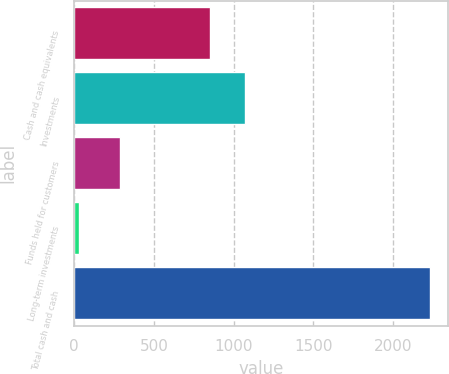Convert chart. <chart><loc_0><loc_0><loc_500><loc_500><bar_chart><fcel>Cash and cash equivalents<fcel>Investments<fcel>Funds held for customers<fcel>Long-term investments<fcel>Total cash and cash<nl><fcel>849<fcel>1069.3<fcel>289<fcel>31<fcel>2234<nl></chart> 